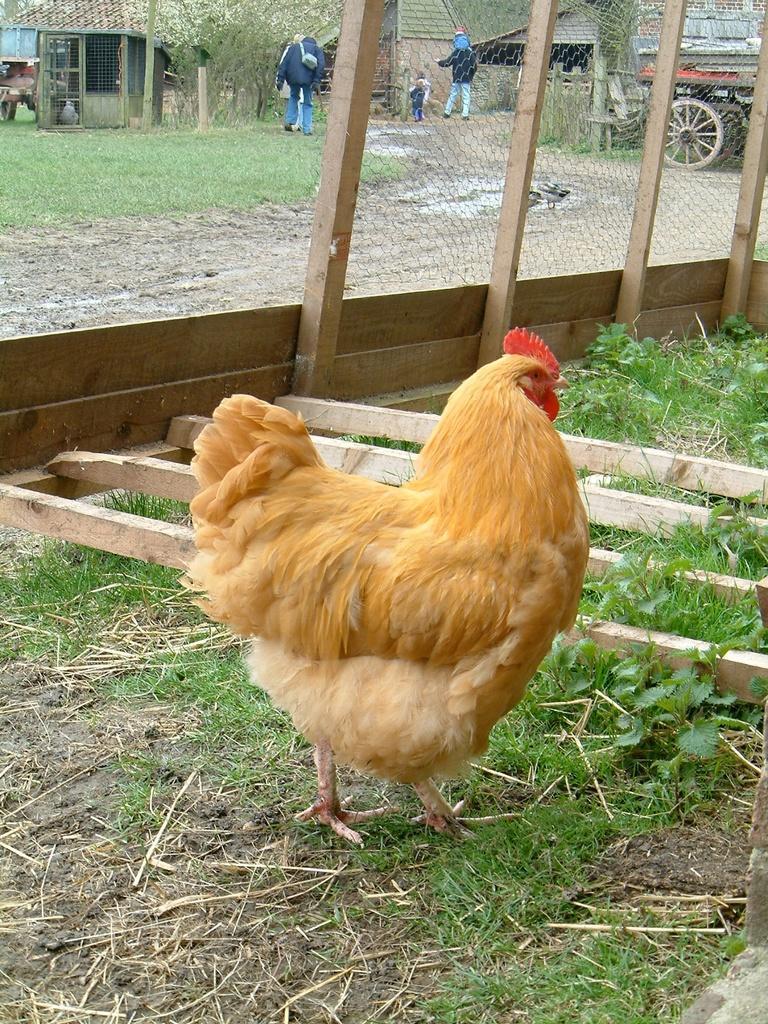How would you summarize this image in a sentence or two? In front of the picture, we see hen. At the bottom, we see grass and herbs. Beside that, we see wooden sticks. Behind that, we see a fence. In the right top, we see a vehicle. In the middle of the picture, we see three men are walking. There are trees, buildings and a vehicle at the top. 